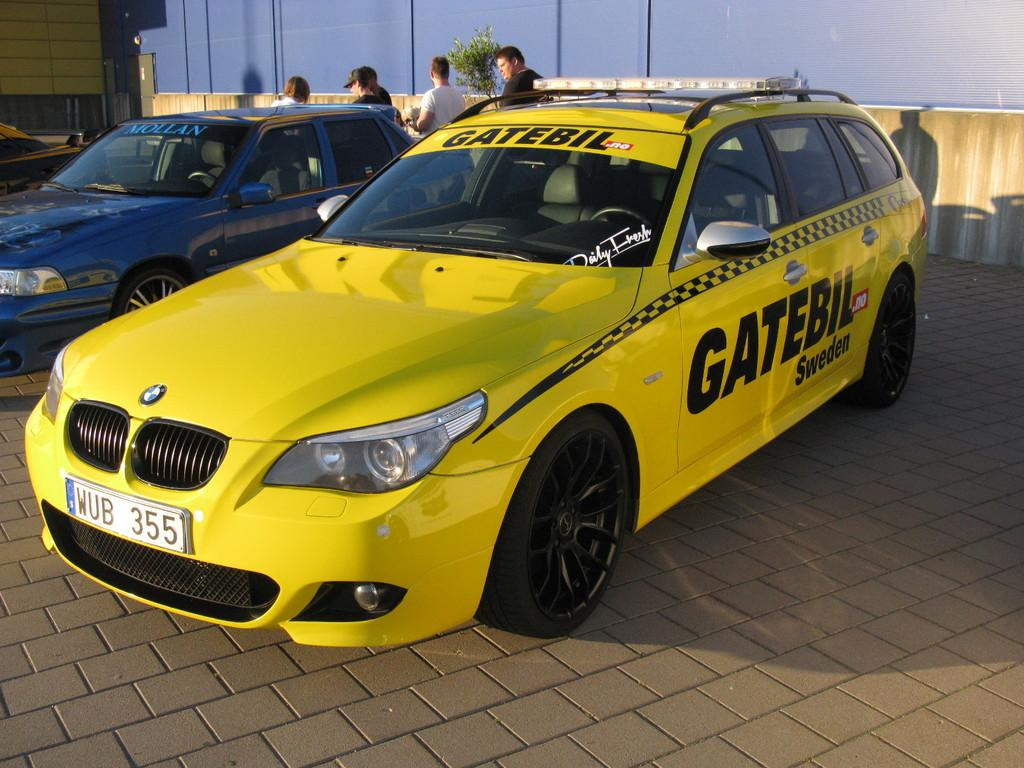What vehicles are present in the image? There are two cars in the front of the image. What else can be seen in the background of the image? There are people standing in the background of the image, as well as a plant. What is located on the left side of the image? There is a wall on the left side of the image. What type of pin is being used by the secretary in the image? There is no secretary or pin present in the image. What type of rake is being used by the people in the background of the image? There are no rakes present in the image; the people are simply standing in the background. 